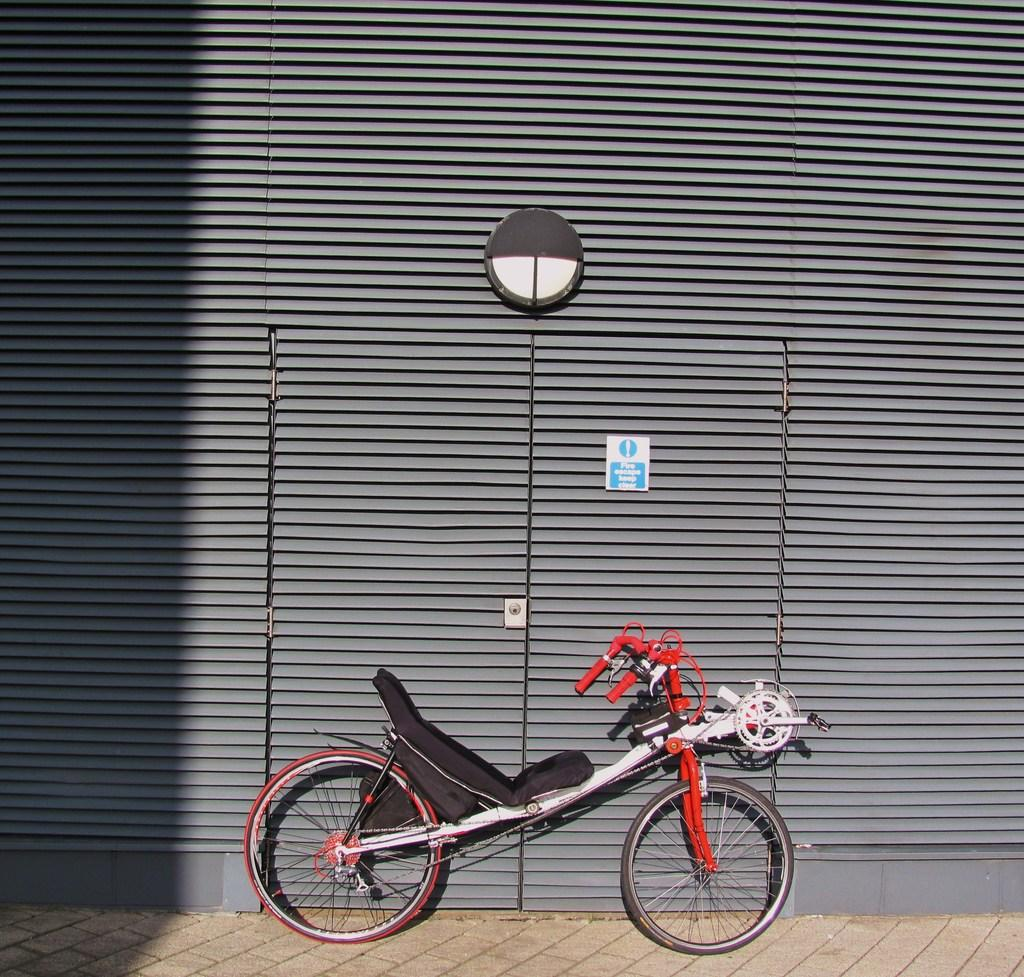What can be seen at the bottom of the picture? There is a bicycle and a pavement at the bottom of the picture. What type of structure is visible in the image? There is a wall in the image, and there is also a door. Are there any other objects in the image besides the bicycle and the wall? Yes, there are other objects in the image. What type of pizzas are being discussed by the committee in the image? There is no mention of pizzas or a committee in the image. Is there a ship visible in the image? No, there is no ship present in the image. 